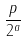Convert formula to latex. <formula><loc_0><loc_0><loc_500><loc_500>\frac { p } { 2 ^ { a } }</formula> 